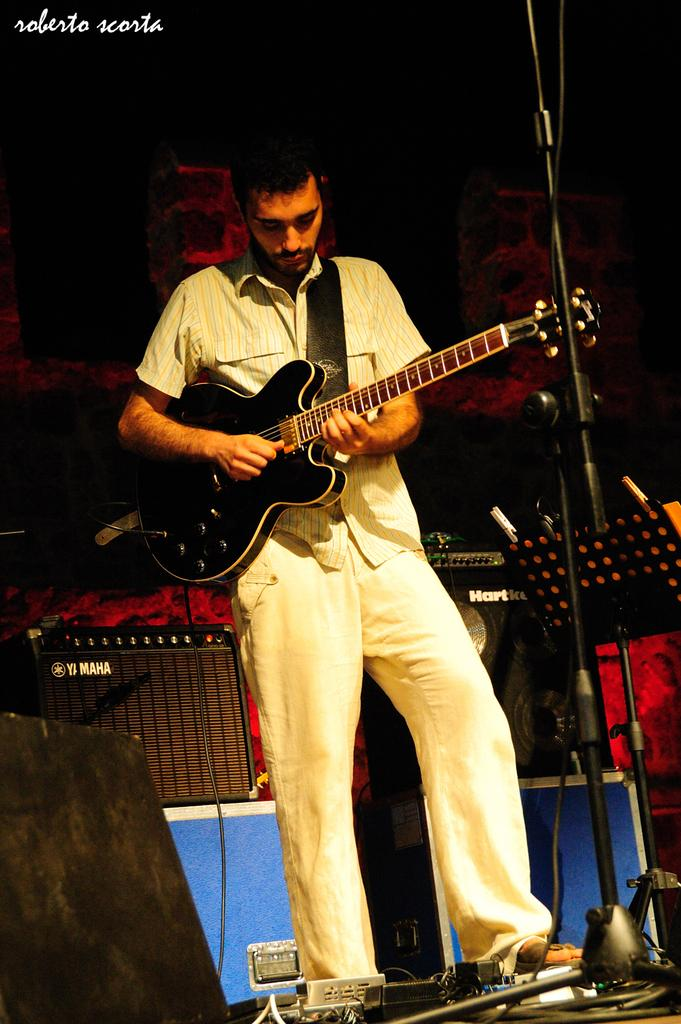What is the main subject of the image? The main subject of the image is a man. What is the man doing in the image? The man is playing a guitar in the image. What type of straw is the man using to play the guitar in the image? There is no straw present in the image, and the man is playing the guitar with his hands. 